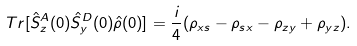<formula> <loc_0><loc_0><loc_500><loc_500>T r [ \hat { S } _ { z } ^ { A } ( 0 ) \hat { S } _ { y } ^ { D } ( 0 ) \hat { \rho } ( 0 ) ] = \frac { i } { 4 } ( \rho _ { x s } - \rho _ { s x } - \rho _ { z y } + \rho _ { y z } ) .</formula> 